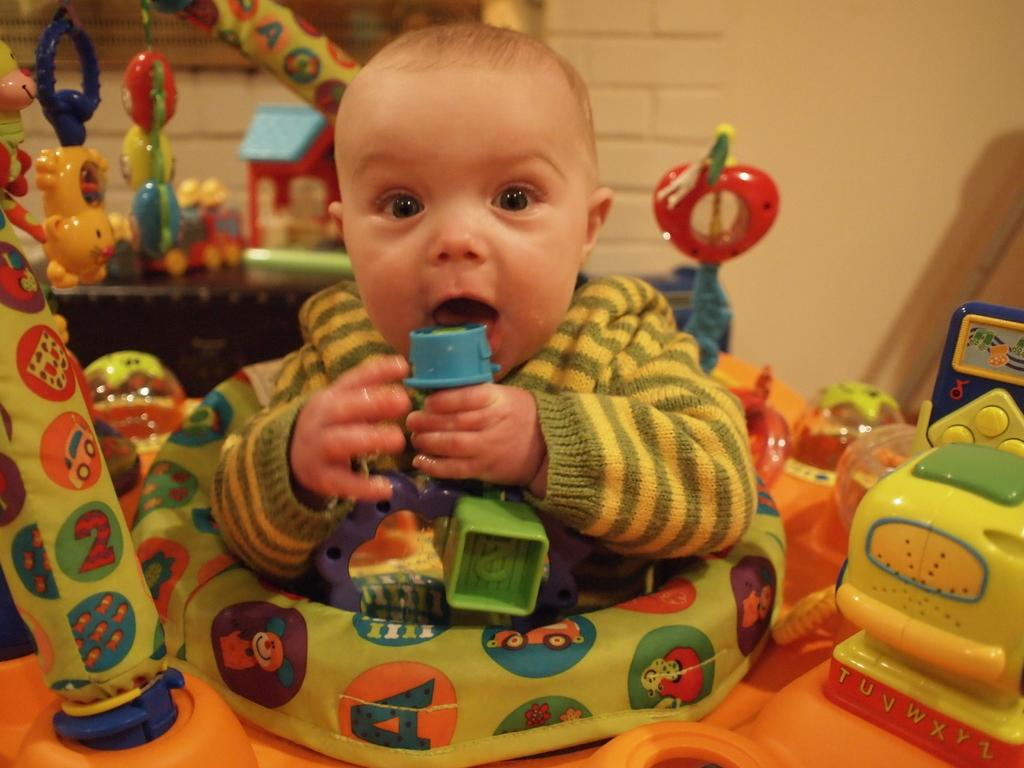What is the main subject of the image? There is a baby in the image. What is the baby holding in the image? The baby is holding a toy. Can you describe the baby's clothing? The baby is wearing a green and yellow dress. What can be seen in the background of the image? There are toys in the background of the image. What colors are the toys in the background? The toys are in multiple colors. What color is the wall in the background? The wall in the background is cream-colored. What type of print can be seen on the baby's dress? There is no print visible on the baby's dress; it is a solid green and yellow color. How does the station produce the toys in the image? There is no station present in the image, and the toys are not being produced; they are already in the background. 